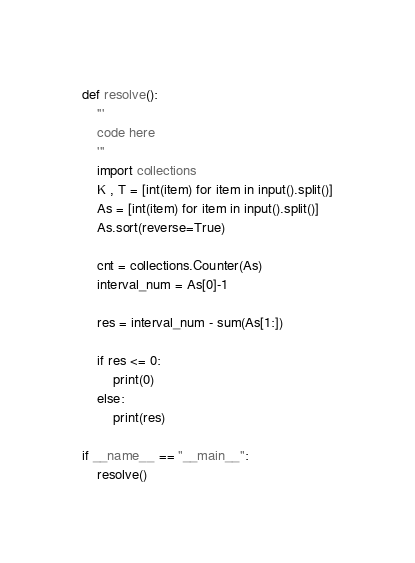<code> <loc_0><loc_0><loc_500><loc_500><_Python_>def resolve():
    '''
    code here
    '''
    import collections
    K , T = [int(item) for item in input().split()]
    As = [int(item) for item in input().split()]
    As.sort(reverse=True)

    cnt = collections.Counter(As)
    interval_num = As[0]-1

    res = interval_num - sum(As[1:])

    if res <= 0:
        print(0)
    else:
        print(res)

if __name__ == "__main__":
    resolve()
</code> 